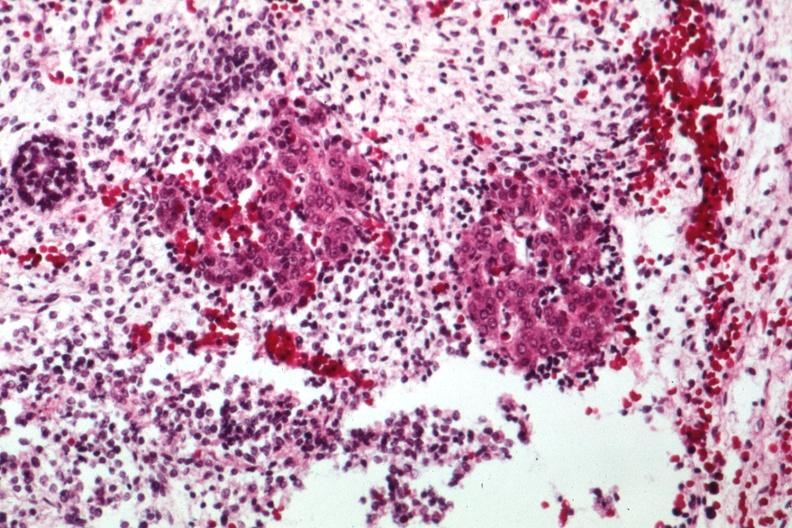what is present?
Answer the question using a single word or phrase. Sacrococcygeal teratoma 